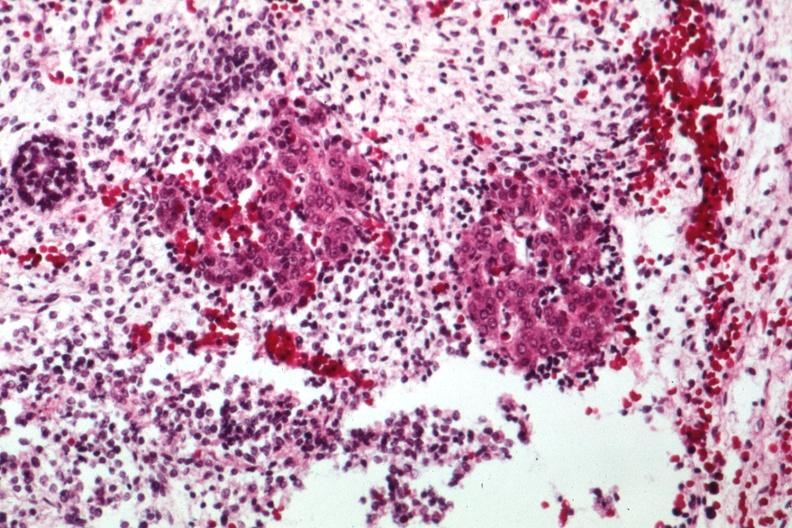what is present?
Answer the question using a single word or phrase. Sacrococcygeal teratoma 